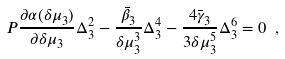<formula> <loc_0><loc_0><loc_500><loc_500>P \frac { \partial \alpha ( \delta \mu _ { 3 } ) } { \partial \delta \mu _ { 3 } } \Delta _ { 3 } ^ { 2 } - \frac { \bar { \beta } _ { 3 } } { \delta \mu _ { 3 } ^ { 3 } } \Delta _ { 3 } ^ { 4 } - \frac { 4 \bar { \gamma } _ { 3 } } { 3 \delta \mu _ { 3 } ^ { 5 } } \Delta _ { 3 } ^ { 6 } = 0 \ ,</formula> 